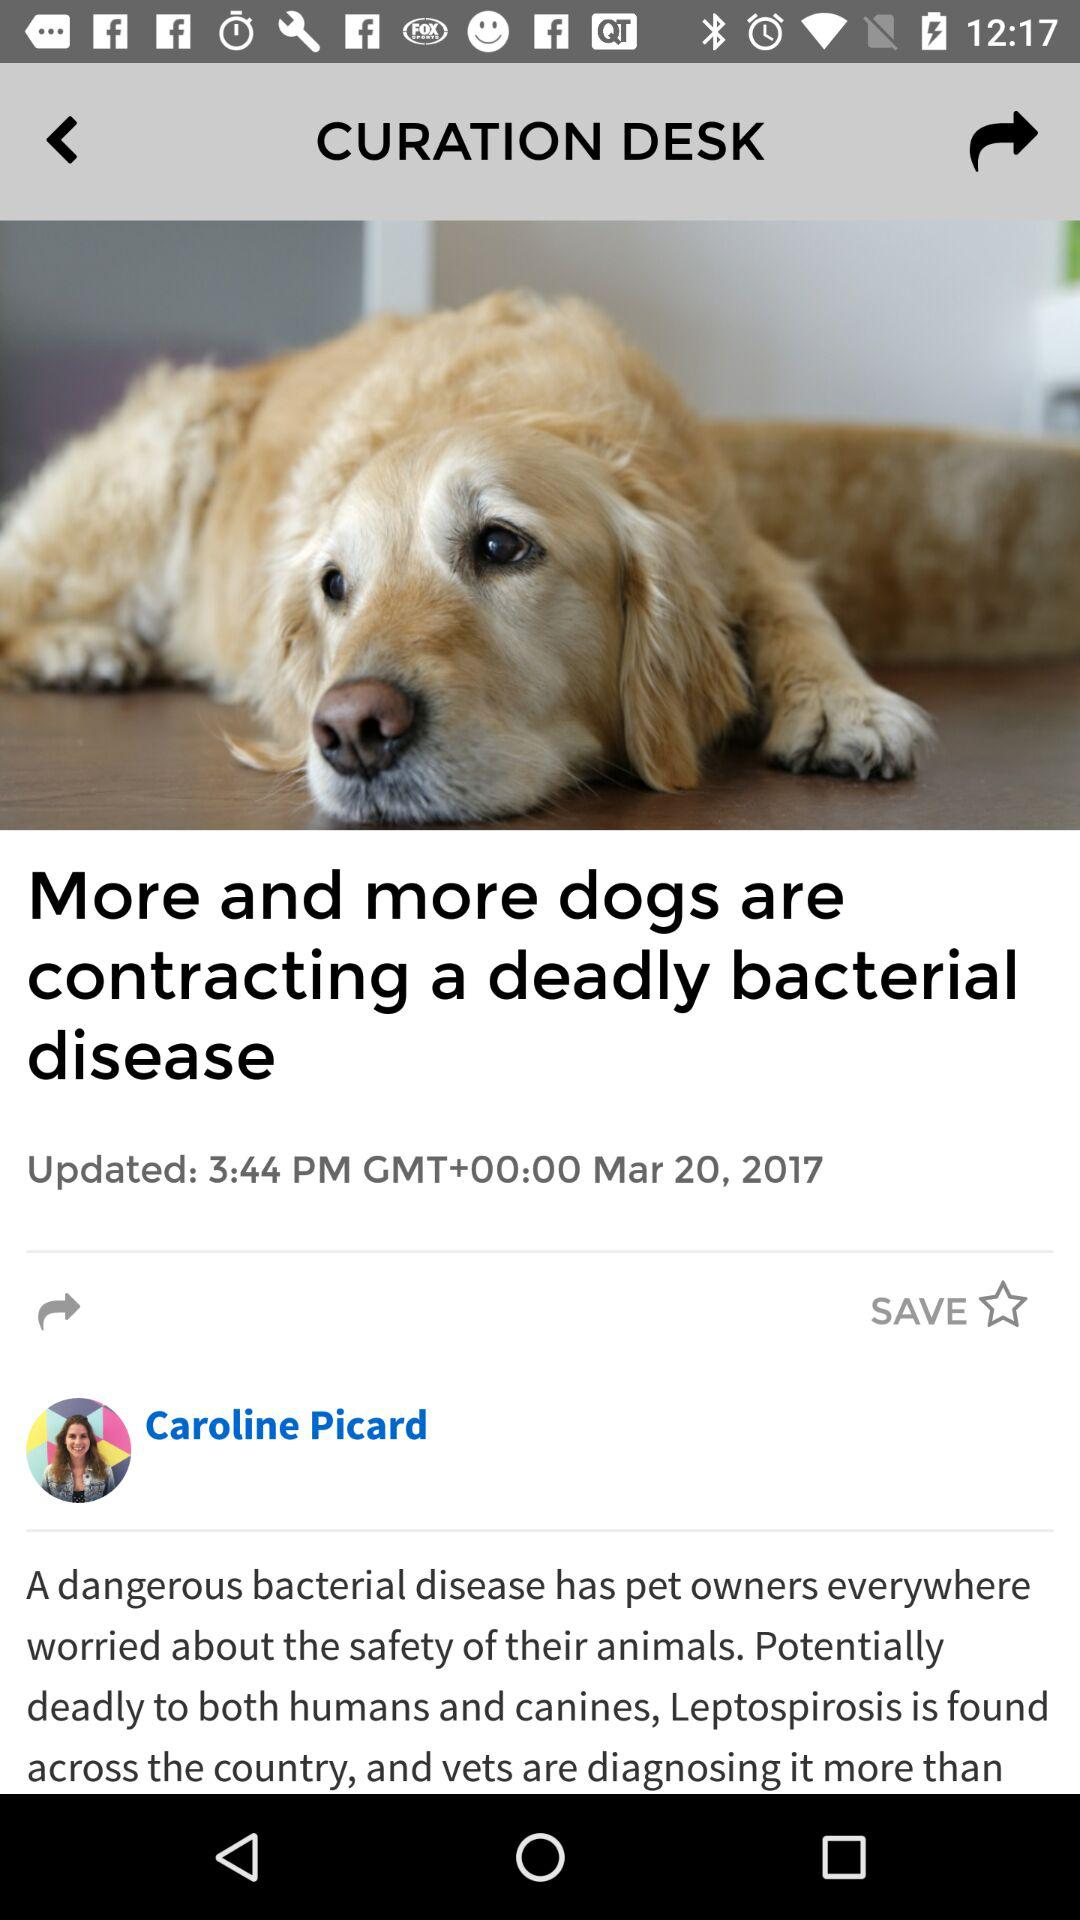What is the updated time? The updated time is 3:44 PM. 